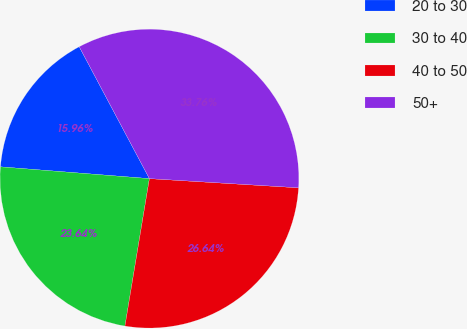<chart> <loc_0><loc_0><loc_500><loc_500><pie_chart><fcel>20 to 30<fcel>30 to 40<fcel>40 to 50<fcel>50+<nl><fcel>15.96%<fcel>23.64%<fcel>26.64%<fcel>33.76%<nl></chart> 